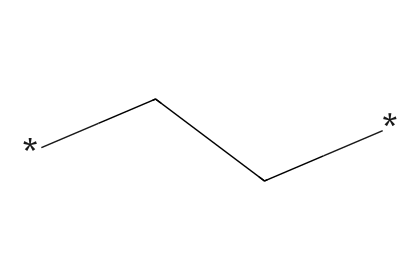What is the chemical name of this structure? The SMILES representation corresponds to a polymer made up of repeating units of ethylene. Thus, the chemical name is polyethylene.
Answer: polyethylene How many carbon atoms are present in the structure? The SMILES representation contains two carbon atoms (indicated by the two 'C's in the string).
Answer: two What type of bonds are primarily present in this chemical? The structure consists of carbon-to-carbon (C-C) and carbon-to-hydrogen (C-H) single bonds, which are typical in saturated hydrocarbons like polyethylene.
Answer: single bonds What is the degree of saturation in this molecule? The absence of double or triple bonds in the chemical structure indicates that the molecule is fully saturated, meaning it has a degree of saturation of zero.
Answer: zero How would you classify polyethylene based on its electrical conductivity? Polyethylene is classified as a non-electrolyte because it does not dissociate into ions in solution, hence does not conduct electricity.
Answer: non-electrolyte What is the approximate molecular weight of polyethylene based on this structure? The molecular formula for polyethylene based on two carbon atoms is C2H4. The molecular weight can be calculated as (2 x atomic weight of C + 4 x atomic weight of H), which results in approximately 28 grams per mole.
Answer: twenty-eight grams per mole What is the impact of the chemical structure on the flexibility of polyethylene? The linear structure of polyethylene, with long chains of carbon atoms, allows it to accommodate bending and stretching, which contributes to its flexibility.
Answer: flexibility 